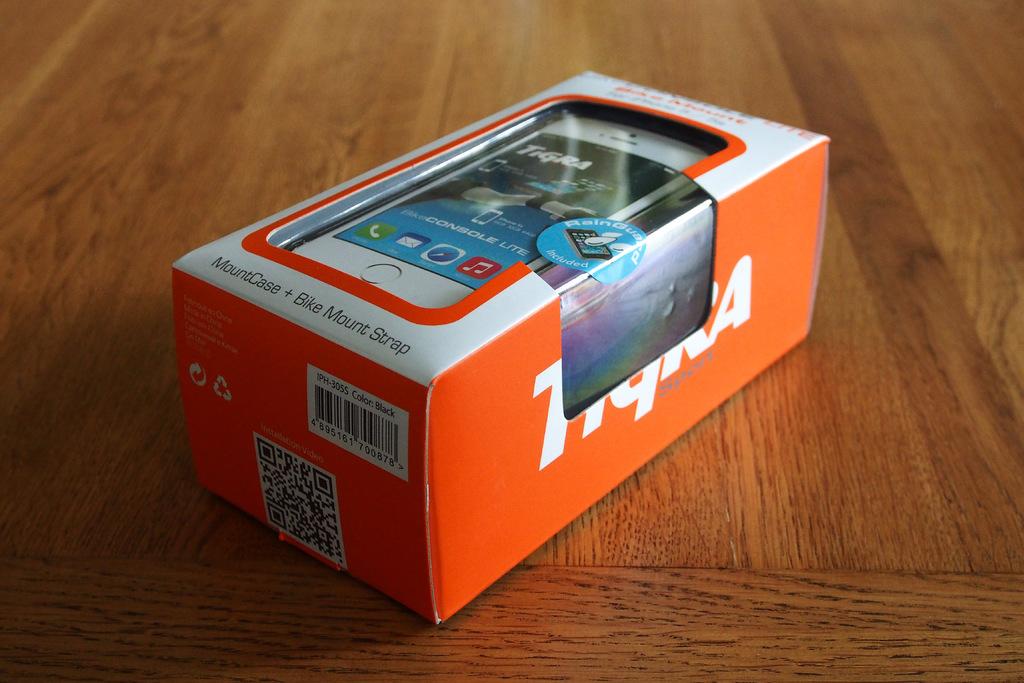What kind of case is this?
Offer a terse response. Mount case. 